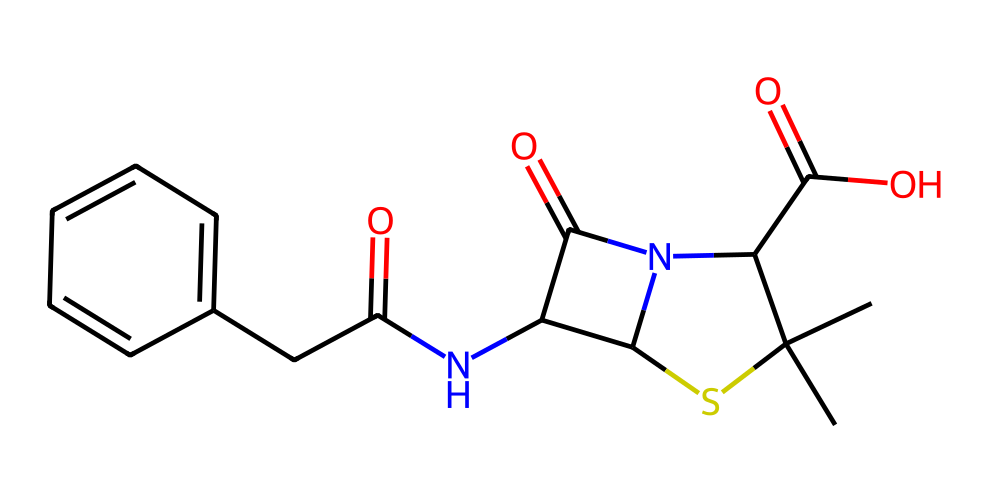What is the total number of carbon atoms in this compound? By examining the SMILES representation, we can count the carbon atoms. The structure contains multiple 'C' entries, which indicate carbon atoms. Counting each 'C' in the representation yields a total of 12 carbon atoms.
Answer: 12 How many nitrogen atoms are present in the molecule? In the SMILES, we can locate the 'N' symbols that indicate nitrogen atoms. There are 3 'N' entries present in the structure, indicating the presence of three nitrogen atoms in this compound.
Answer: 3 Is there any sulfur atom present in this antibiotic? The presence of 'S' in the SMILES denotes the sulfur atom, and there is one 'S' in the representation, confirming that this antibiotic does indeed contain a sulfur atom.
Answer: yes What type of compound is penicillin classified as? Penicillin is known to be a β-lactam antibiotic, characterized by the presence of a β-lactam ring structure which includes both carbon and a nitrogen atom. This specific characteristic allows it to inhibit bacterial cell wall synthesis.
Answer: β-lactam antibiotic What is the functional group that indicates the presence of a carboxylic acid in the structure? The presence of the '-COOH' structure found in the SMILES indicates that there is a carboxylic acid functional group in the compound. This can be identified by the carbonyl (C=O) and hydroxyl (-OH) functional groups combined.
Answer: carboxylic acid How does the sulfur atom contribute to the reactivity of penicillin? The sulfur atom's nucleophilic nature plays a vital role in the mechanism of action of penicillin. It is involved in the formation of covalent bonds with bacterial enzymes, leading to the inhibition of cell wall synthesis, thus signaling its reactivity.
Answer: nucleophilic 